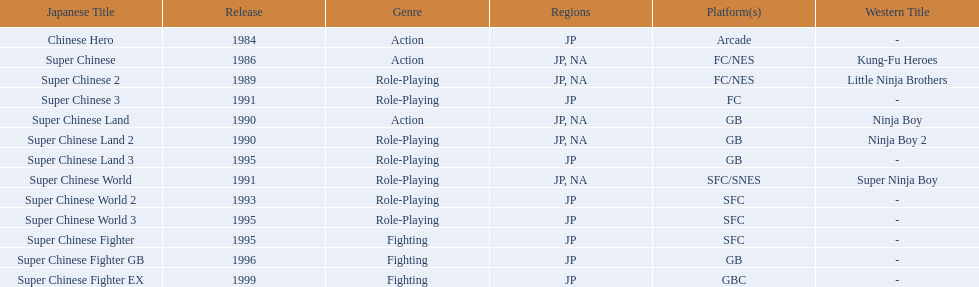In north america, how many action games have been made available? 2. 